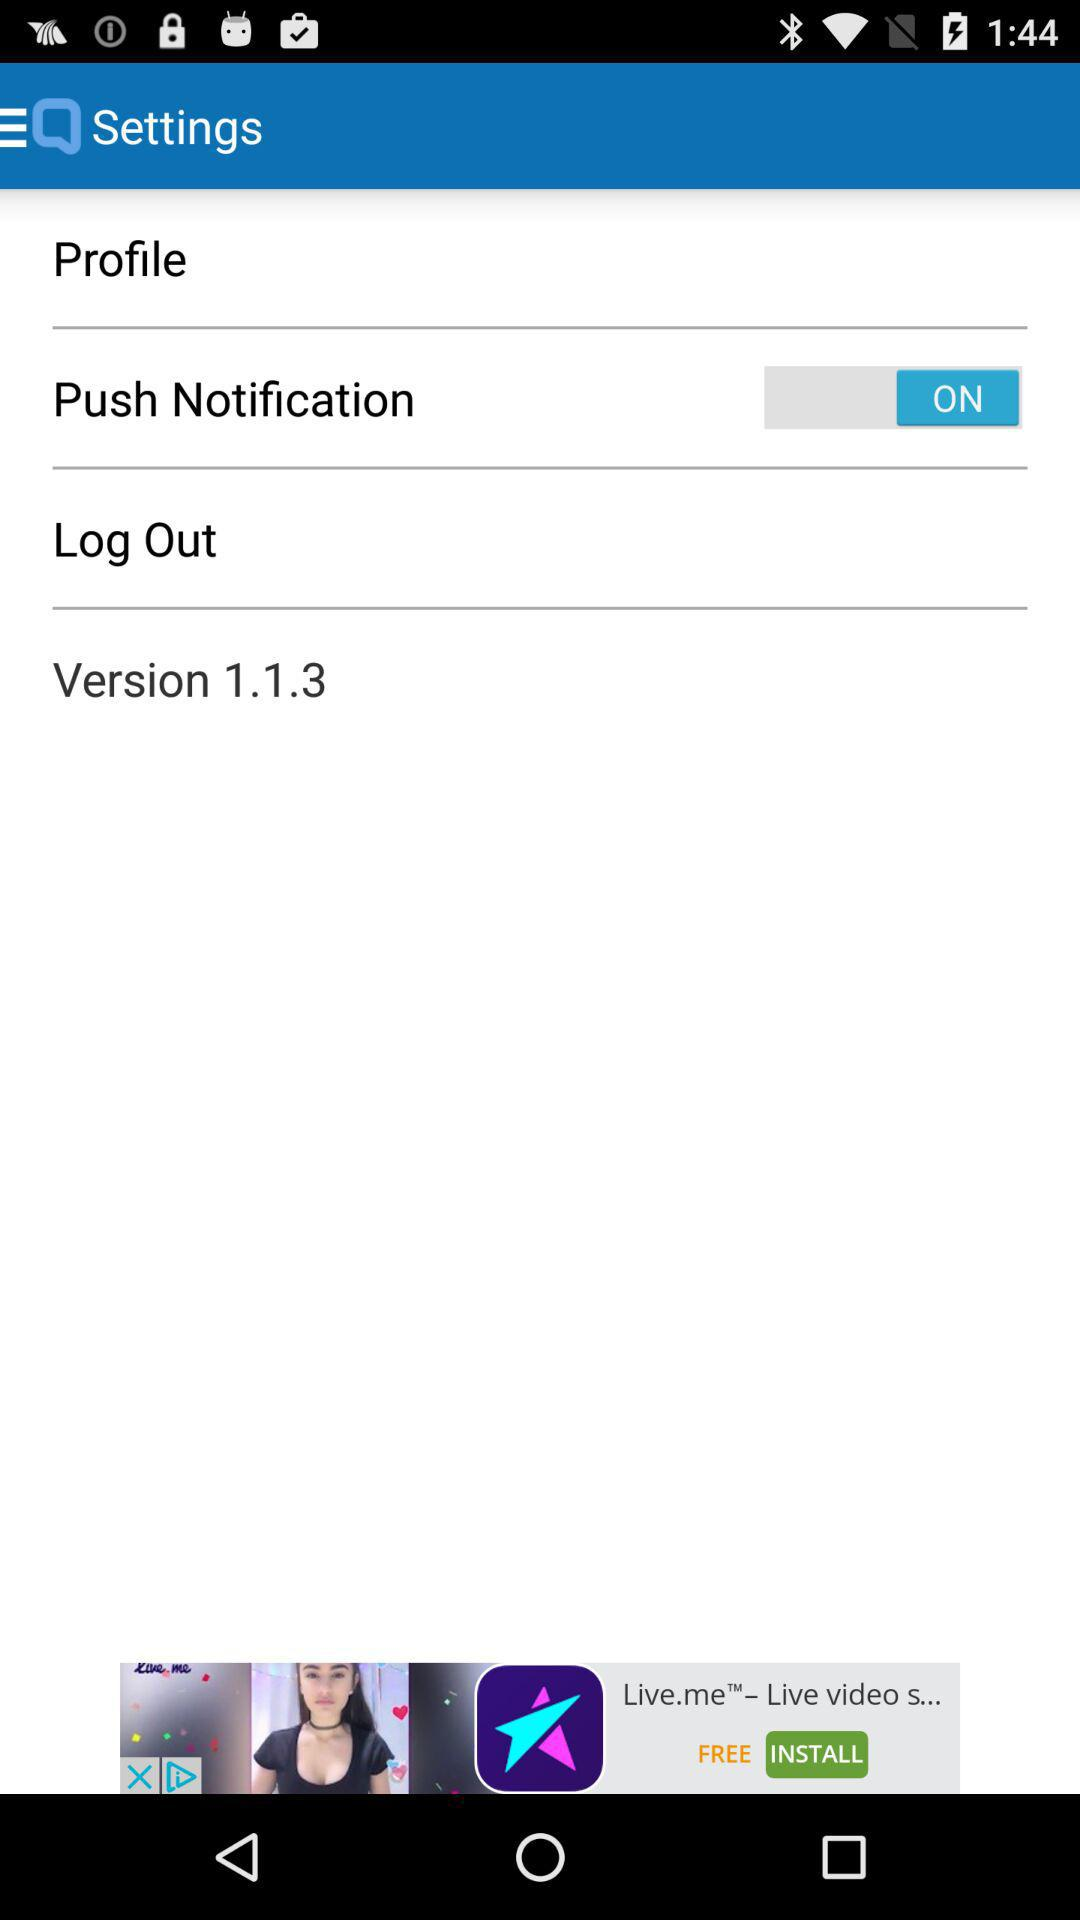What is the status of "Push Notification"? The status is "ON". 